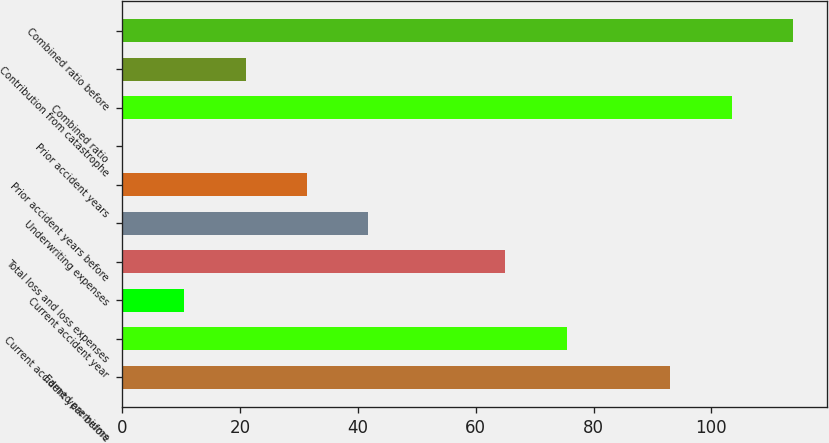Convert chart. <chart><loc_0><loc_0><loc_500><loc_500><bar_chart><fcel>Earned premiums<fcel>Current accident year before<fcel>Current accident year<fcel>Total loss and loss expenses<fcel>Underwriting expenses<fcel>Prior accident years before<fcel>Prior accident years<fcel>Combined ratio<fcel>Contribution from catastrophe<fcel>Combined ratio before<nl><fcel>93<fcel>75.43<fcel>10.53<fcel>65<fcel>41.82<fcel>31.39<fcel>0.1<fcel>103.43<fcel>20.96<fcel>113.86<nl></chart> 